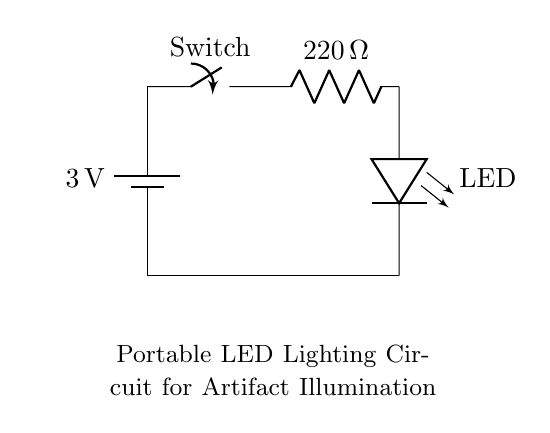What is the voltage of this circuit? The circuit has a battery labeled with a voltage of 3 volts, which indicates the potential difference supplied to the circuit.
Answer: 3 volts What type of switch is used in this circuit? The circuit diagram indicates the presence of a switch, which is labeled simply as "Switch," implying it is a basic manual switch that can open or close the circuit.
Answer: Switch What is the resistance value in this circuit? The circuit diagram displays a resistor labeled with a value of 220 ohms, which is the amount of resistance in the circuit.
Answer: 220 ohms How many components are used in the circuit? By counting the visible components in the diagram, there are five distinct elements: the battery, switch, resistor, LED, and the circuit connection.
Answer: Five What is the function of the LED in this circuit? The LED (Light Emitting Diode) is labeled in the diagram, and its primary function in this circuit is to emit light when electrical current flows through it, indicating illumination.
Answer: Illumination What happens to the LED if the switch is open? When the switch is open, the circuit is incomplete, preventing current from flowing, which means the LED will not light up.
Answer: It will not light up Why is a resistor included in this circuit? The resistor is included to limit the current flowing through the LED to a safe level, preventing damage due to excess current, ensuring that the LED operates efficiently and has a longer lifespan.
Answer: To limit current 